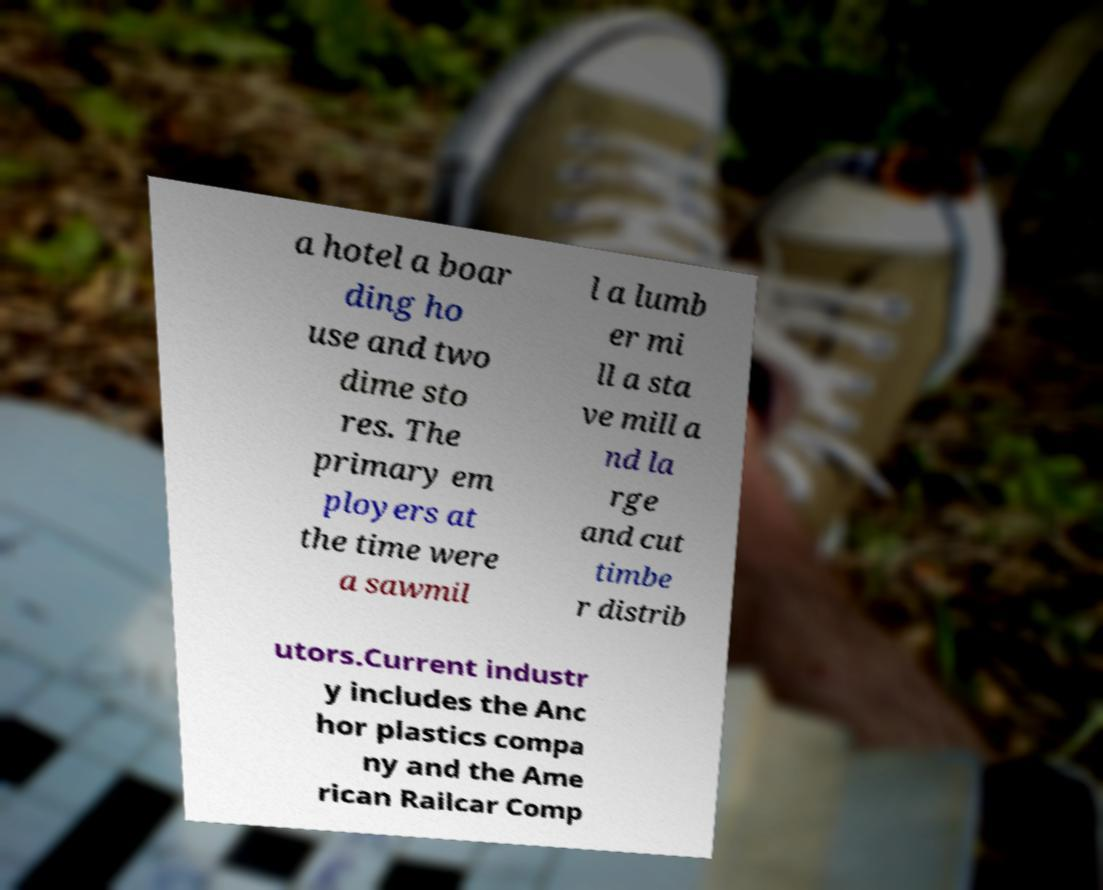For documentation purposes, I need the text within this image transcribed. Could you provide that? a hotel a boar ding ho use and two dime sto res. The primary em ployers at the time were a sawmil l a lumb er mi ll a sta ve mill a nd la rge and cut timbe r distrib utors.Current industr y includes the Anc hor plastics compa ny and the Ame rican Railcar Comp 